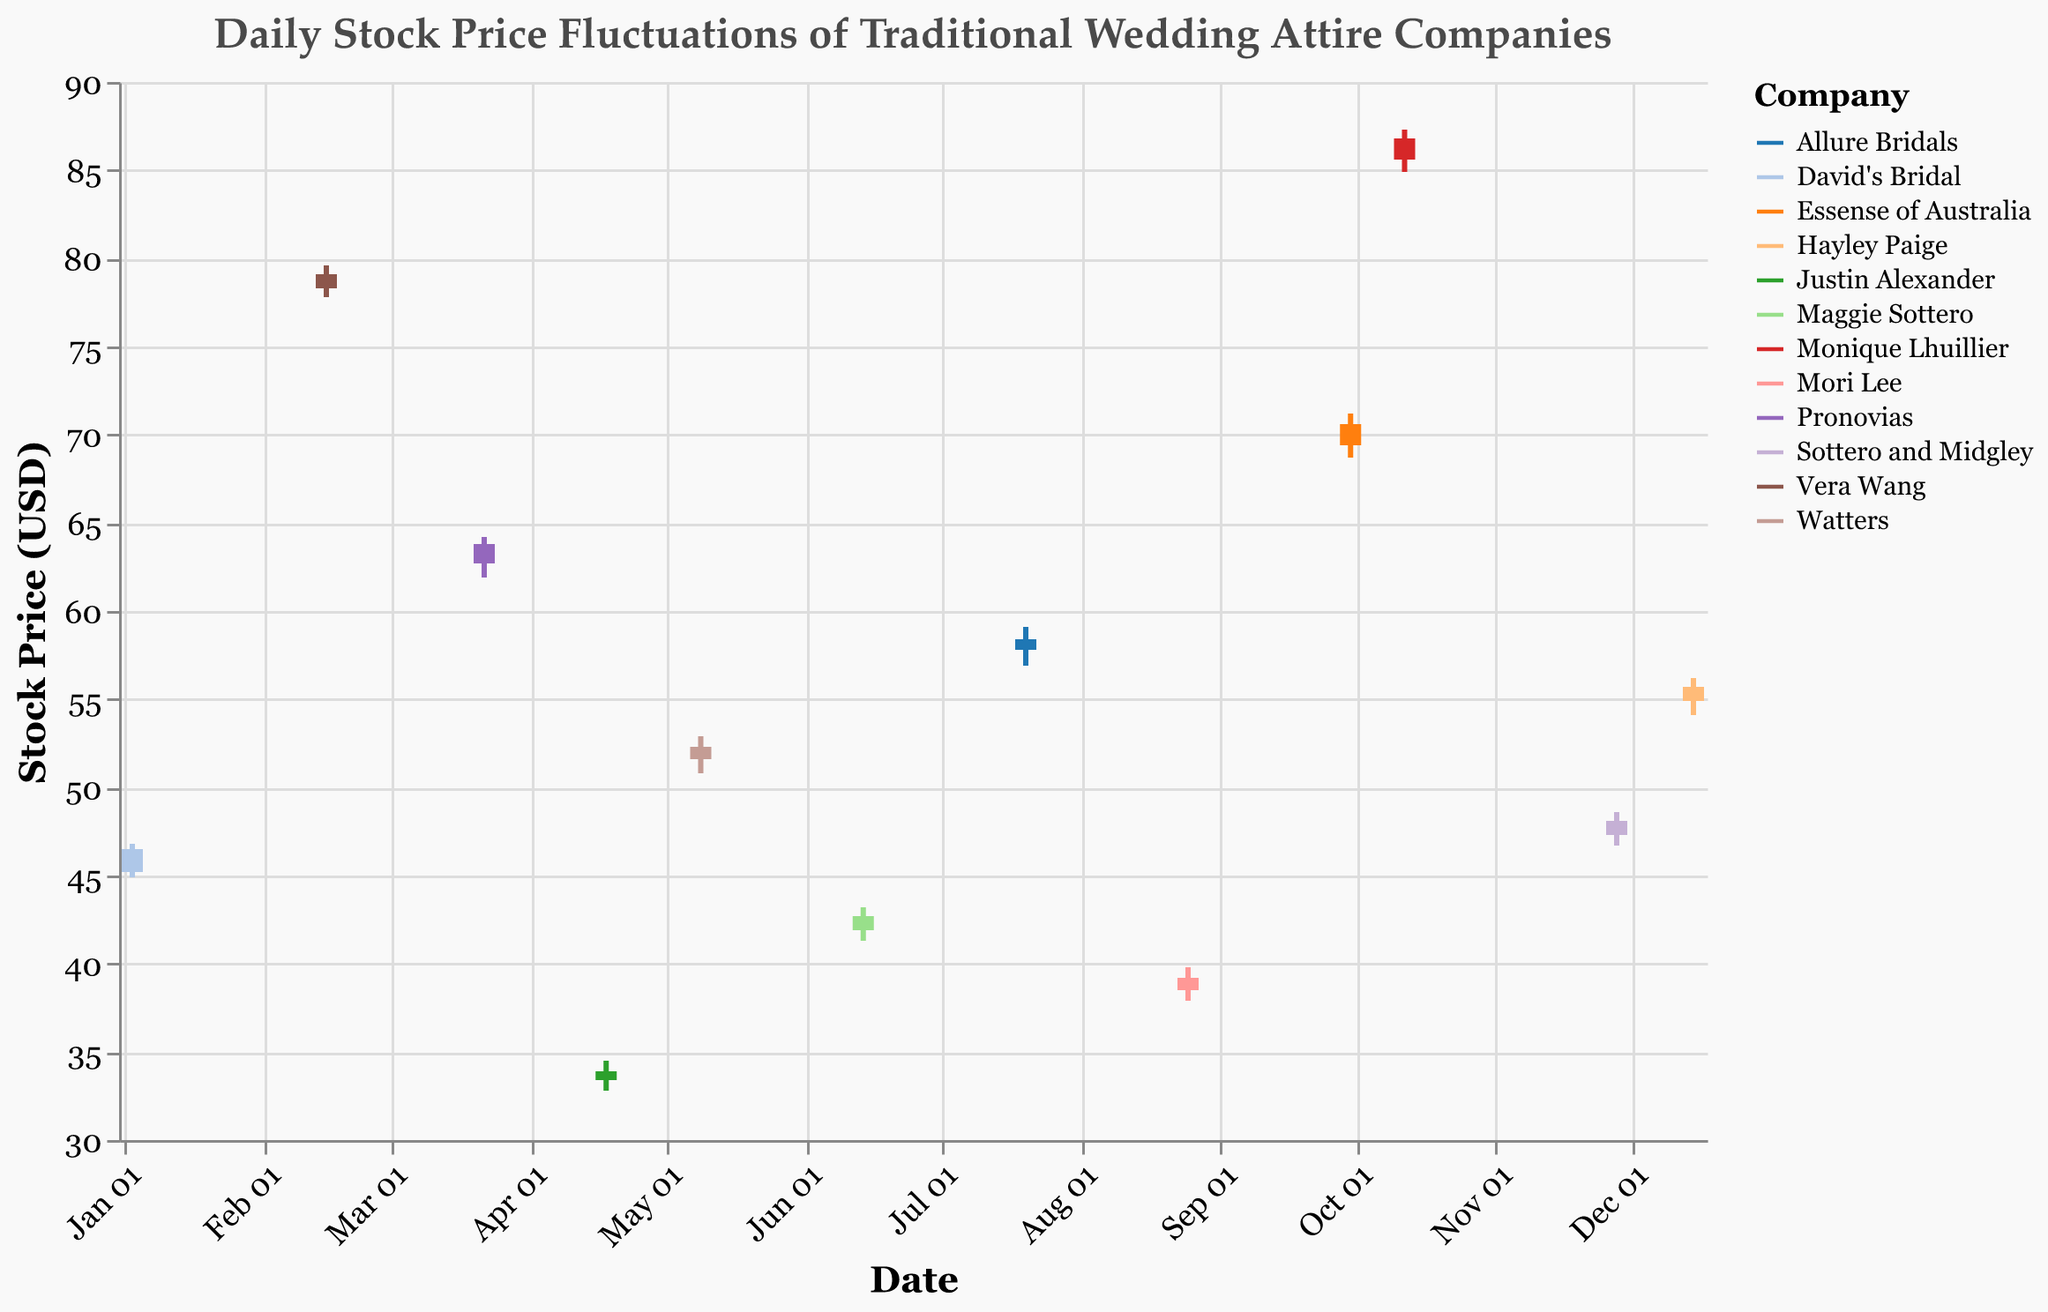What is the title of the chart? The title of the chart is located at the top and reads "Daily Stock Price Fluctuations of Traditional Wedding Attire Companies."
Answer: Daily Stock Price Fluctuations of Traditional Wedding Attire Companies How is the x-axis labeled and formatted? The x-axis represents the 'Date' and it is formatted to show the month and day (e.g., Jan 03, Feb 15) with labels angled at -45 degrees.
Answer: Date, with labels like Jan 03, Feb 15 Which company's stock had the highest closing price? By examining the 'Close' prices across all companies, Monique Lhuillier had the highest closing price at 86.80 USD on Oct 12.
Answer: Monique Lhuillier On which date did Pronovias see its highest price of the day, and what was that price? From the figure, Pronovias had its highest price on Mar 22 with a 'High' value of 64.20 USD.
Answer: Mar 22, 64.20 USD Compare the opening and closing prices of Watters. Did the stock price go up or down? The opening price for Watters was 51.60 USD and the closing price was 52.30 USD. Since the closing price is higher, the stock price went up.
Answer: Up What was the greatest difference between the high and low prices on any given date, and for which company? To find the greatest difference, we need to subtract the 'Low' from the 'High' price for each company. Monique Lhuillier had the greatest difference of 2.40 USD (87.30 - 84.90) on Oct 12.
Answer: 2.40 USD, Monique Lhuillier Which company had the lowest closing price, and what was that price? By checking all the closing prices, Justin Alexander had the lowest closing price at 33.90 USD.
Answer: Justin Alexander, 33.90 USD What were the opening and closing prices for Allure Bridals on July 20? From the chart, Allure Bridals opened at 57.80 USD and closed at 58.40 USD on July 20.
Answer: Open: 57.80 USD, Close: 58.40 USD Calculate the average closing price for all companies. To find the average closing price, sum all closing prices and divide by the number of companies: (46.50 + 79.10 + 63.80 + 33.90 + 52.30 + 42.70 + 58.40 + 39.20 + 70.60 + 86.80 + 48.10 + 55.70) / 12 = 54.15 USD
Answer: 54.15 USD On which date did a company have a closing price exactly 1 USD higher than its opening price, and which company was it? Check the differences between 'Open' and 'Close' prices: Watters on May 9 had a closing price (52.30 USD) exactly 1 USD higher than the opening price (51.30 USD).
Answer: May 9, Watters 